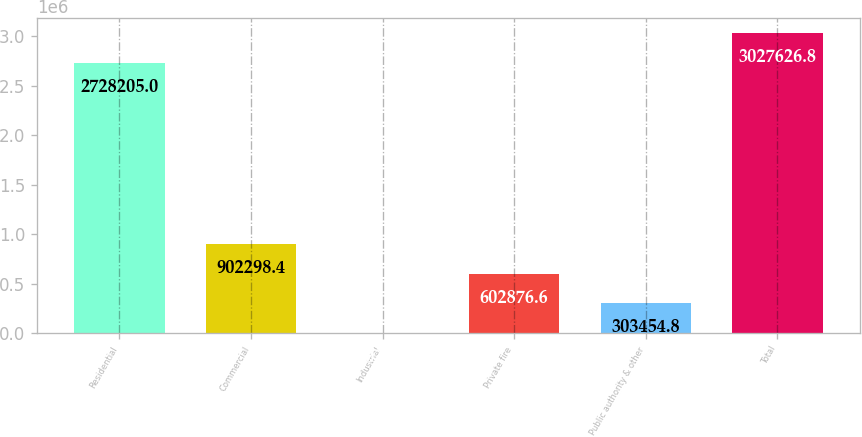Convert chart to OTSL. <chart><loc_0><loc_0><loc_500><loc_500><bar_chart><fcel>Residential<fcel>Commercial<fcel>Industrial<fcel>Private fire<fcel>Public authority & other<fcel>Total<nl><fcel>2.7282e+06<fcel>902298<fcel>4033<fcel>602877<fcel>303455<fcel>3.02763e+06<nl></chart> 